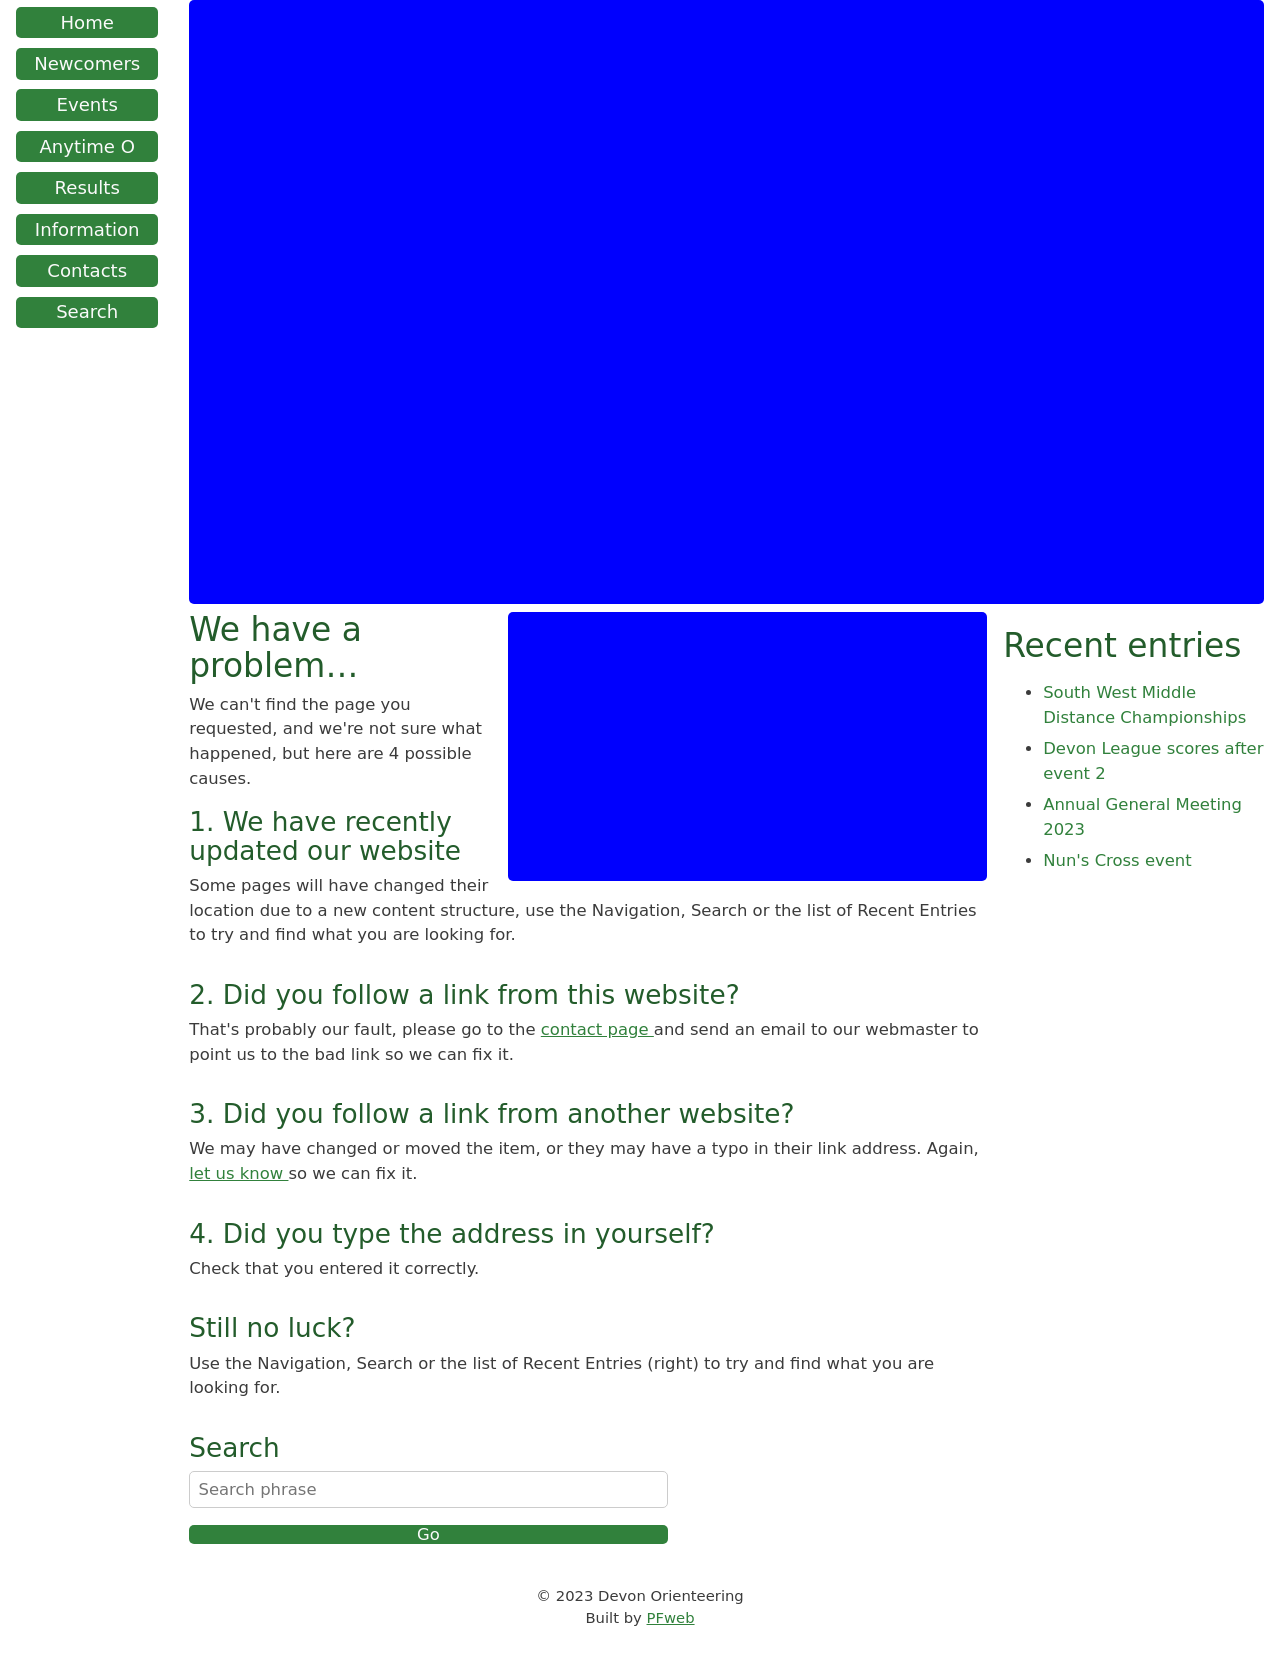What are some potential reasons a user might encounter the error screen shown in the image? The error screen you’re referring to typically appears under a few common circumstances: 1. The website has recently been updated or restructured, causing URL changes. 2. There might be broken or outdated links within the site leading to non-existent pages. 3. External links pointing to the site could contain typographical errors in the URL. 4. The user might have mistyped the URL. It’s designed to provide users with possible next steps to find the information they need or report the issue. 